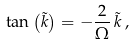<formula> <loc_0><loc_0><loc_500><loc_500>\tan \left ( \tilde { k } \right ) = - \frac { 2 } { \Omega } \, \tilde { k } \, ,</formula> 